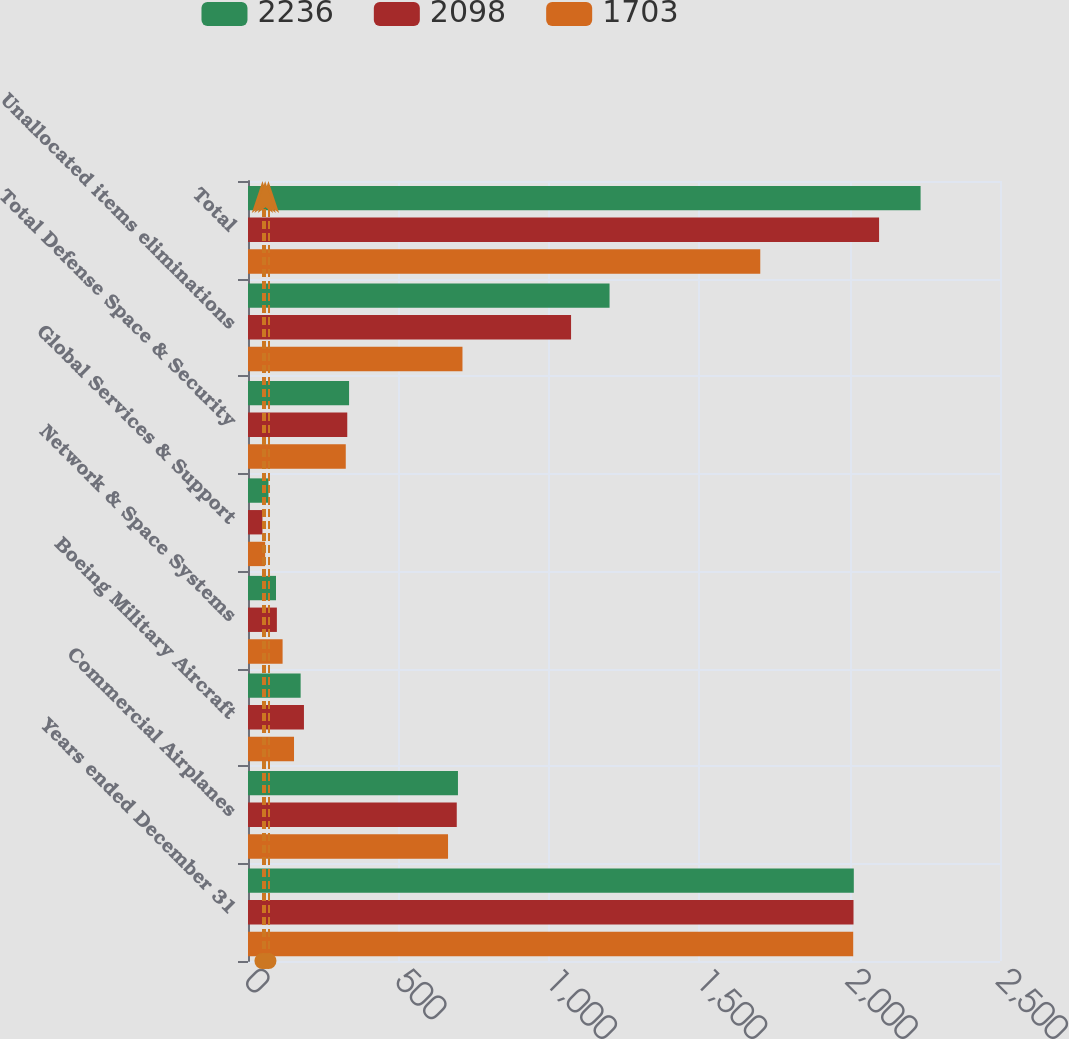<chart> <loc_0><loc_0><loc_500><loc_500><stacked_bar_chart><ecel><fcel>Years ended December 31<fcel>Commercial Airplanes<fcel>Boeing Military Aircraft<fcel>Network & Space Systems<fcel>Global Services & Support<fcel>Total Defense Space & Security<fcel>Unallocated items eliminations<fcel>Total<nl><fcel>2236<fcel>2014<fcel>698<fcel>175<fcel>93<fcel>68<fcel>336<fcel>1202<fcel>2236<nl><fcel>2098<fcel>2013<fcel>694<fcel>186<fcel>96<fcel>48<fcel>330<fcel>1074<fcel>2098<nl><fcel>1703<fcel>2012<fcel>665<fcel>153<fcel>115<fcel>57<fcel>325<fcel>713<fcel>1703<nl></chart> 